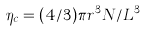Convert formula to latex. <formula><loc_0><loc_0><loc_500><loc_500>\eta _ { c } = ( 4 / 3 ) \pi r ^ { 3 } N / L ^ { 3 }</formula> 